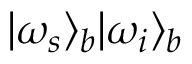Convert formula to latex. <formula><loc_0><loc_0><loc_500><loc_500>| \omega _ { s } \rangle _ { b } | \omega _ { i } \rangle _ { b }</formula> 